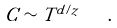Convert formula to latex. <formula><loc_0><loc_0><loc_500><loc_500>C \sim T ^ { d / z } \quad .</formula> 